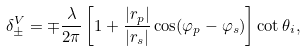Convert formula to latex. <formula><loc_0><loc_0><loc_500><loc_500>\delta _ { \pm } ^ { V } = \mp \frac { \lambda } { 2 \pi } \left [ 1 + \frac { | r _ { p } | } { | r _ { s } | } \cos ( \varphi _ { p } - \varphi _ { s } ) \right ] \cot \theta _ { i } ,</formula> 